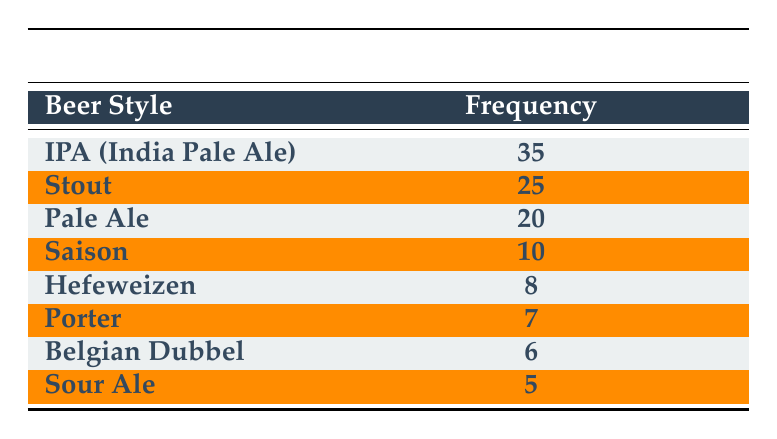What is the most popular beer style according to the table? The table lists the beer styles and their corresponding frequencies. The style with the highest frequency is "IPA (India Pale Ale)" with a frequency of 35.
Answer: IPA (India Pale Ale) How many people surveyed prefer Stout? The frequency for Stout in the table is 25, indicating that 25 people surveyed prefer this beer style.
Answer: 25 What percentage of respondents prefer Pale Ale compared to the total respondents? First, we calculate the total frequency: 35 + 25 + 20 + 10 + 8 + 7 + 6 + 5 = 116. Then we calculate the percentage for Pale Ale: (20 / 116) * 100 = approximately 17.24%.
Answer: 17.24% Is Belgian Dubbel more popular than Porter? By comparing the frequencies in the table, Belgian Dubbel has a frequency of 6 and Porter has a frequency of 7. Since 6 is less than 7, Belgian Dubbel is not more popular than Porter.
Answer: No What is the average frequency of the beer styles listed in the table? To find the average, add the frequencies: 35 + 25 + 20 + 10 + 8 + 7 + 6 + 5 = 116. There are 8 styles, so the average is 116 / 8 = 14.5.
Answer: 14.5 How many styles have a frequency of 10 or less? From the table, we see that the styles with a frequency of 10 or less are Saison (10), Hefeweizen (8), Porter (7), Belgian Dubbel (6), and Sour Ale (5). There are 5 styles in total fitting this criterion.
Answer: 5 What is the difference in frequency between the most popular and least popular beer styles? The most popular style is IPA (India Pale Ale) with a frequency of 35, while the least popular is Sour Ale with a frequency of 5. The difference is 35 - 5 = 30.
Answer: 30 Which beer style has a frequency closest to the average frequency? The average frequency is 14.5. Looking at the frequencies, Hefeweizen (8) and Belgian Dubbel (6) are below, and Pale Ale (20) is above. Pale Ale (20) is closest to the average.
Answer: Pale Ale 